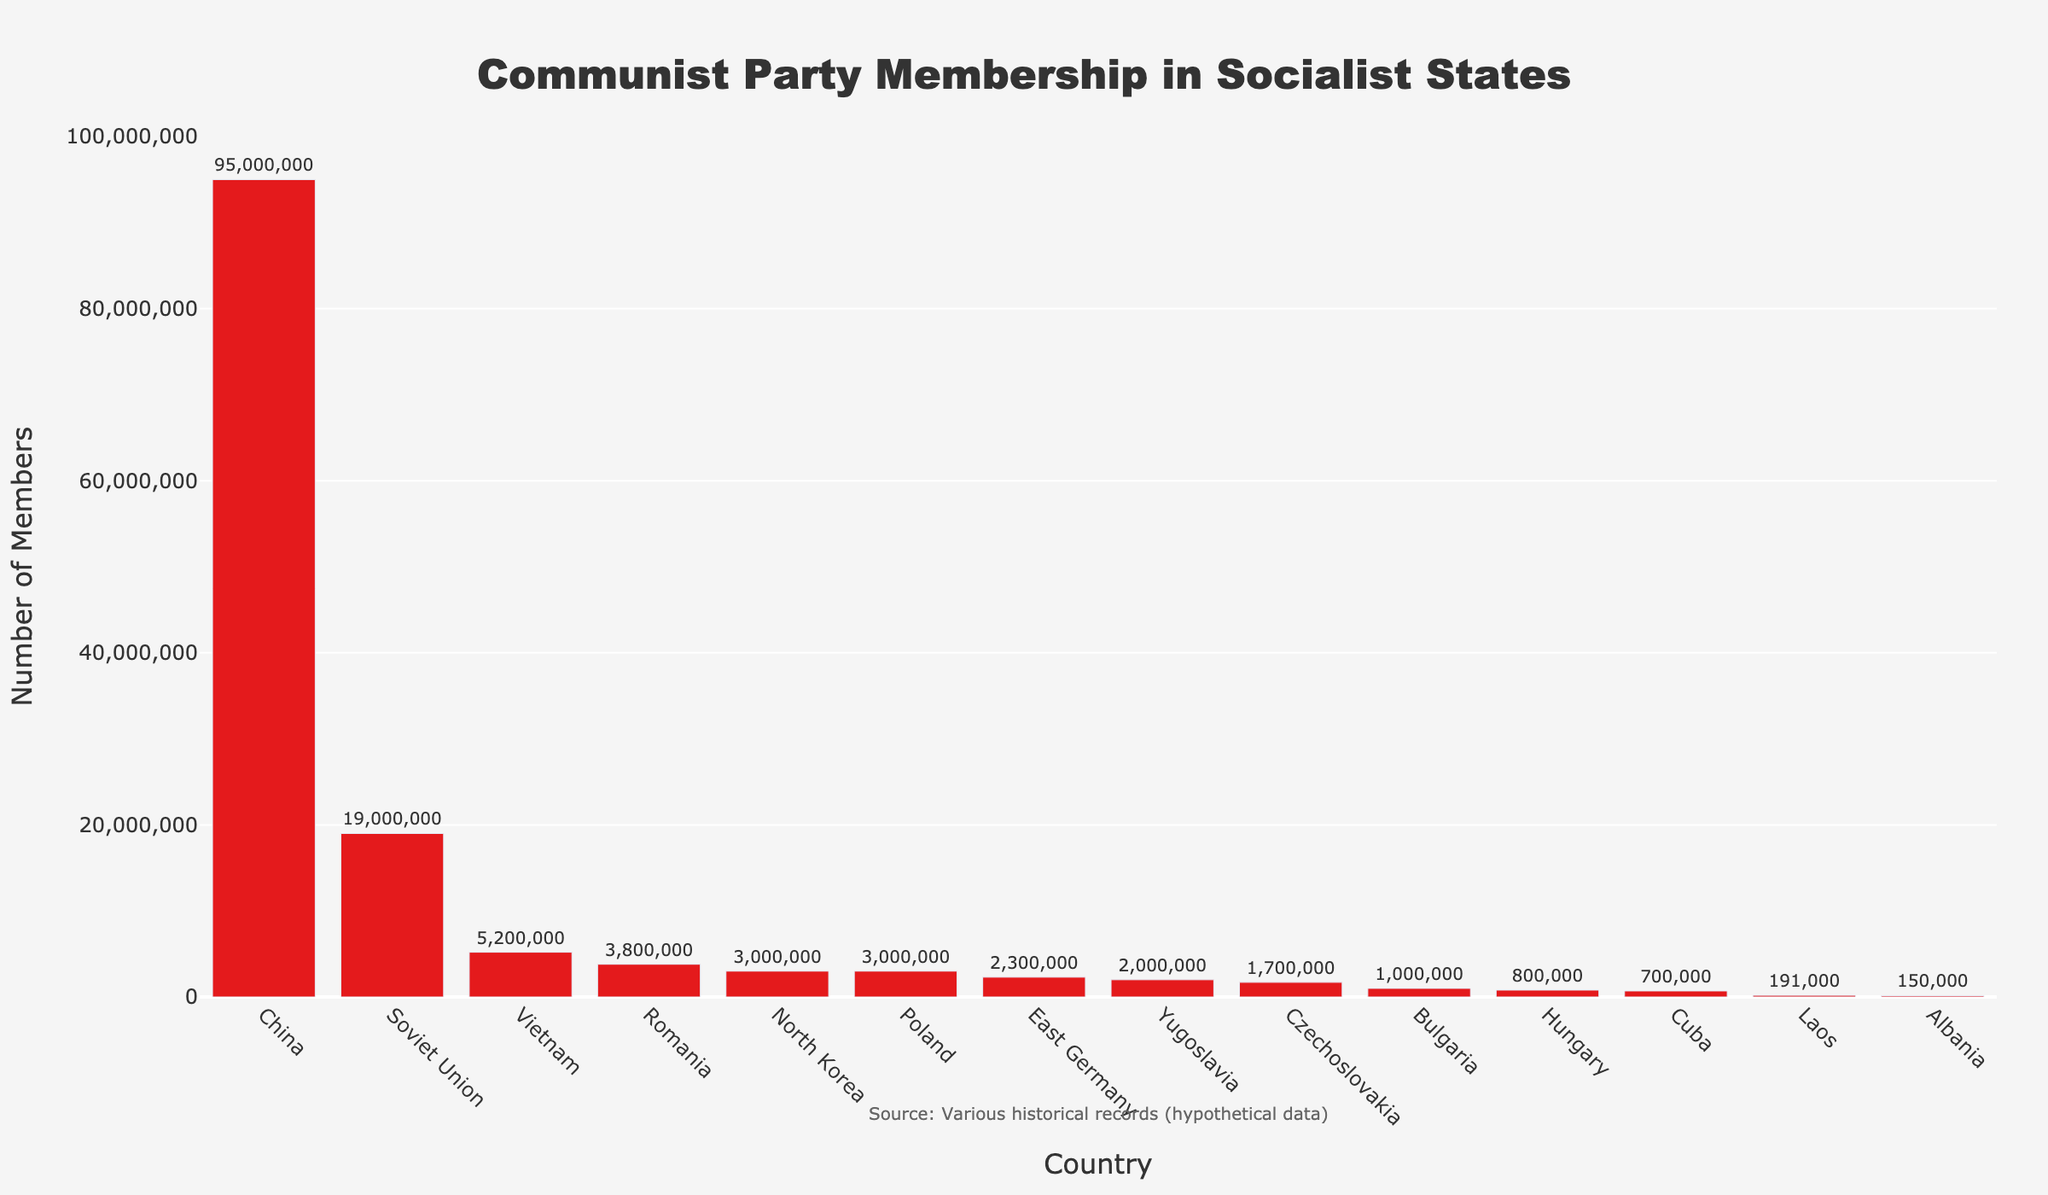what is the country with the second-highest number of Communist Party members? The bar chart shows the number of Communist Party members in several countries. China has the highest number at 95,000,000 members. The country with the second-highest number is the Soviet Union, with 19,000,000 members.
Answer: Soviet Union How many Communist Party members are there in Cuba relative to Vietnam? Look at the heights of the bars for Cuba and Vietnam and note the numbers: Cuba has 700,000 members, and Vietnam has 5,200,000 members. To find the ratio, divide the number of members in Cuba by the number of members in Vietnam: 700,000 / 5,200,000 = 0.1346.
Answer: 0.1346 What is the total number of Communist Party members in all Eastern European countries listed? The Eastern European countries listed are East Germany, Czechoslovakia, Poland, Romania, Bulgaria, Hungary, and Albania. Summing the members: 2,300,000 (East Germany) + 1,700,000 (Czechoslovakia) + 3,000,000 (Poland) + 3,800,000 (Romania) + 1,000,000 (Bulgaria) + 800,000 (Hungary) + 150,000 (Albania) = 12,750,000 members.
Answer: 12,750,000 Which country has the smallest number of Communist Party members? By observing the height of the bars, identify the shortest bar. The country with the smallest number of Communist Party members is Albania, with 150,000 members.
Answer: Albania What's the difference in the number of Communist Party members between the Soviet Union and North Korea? Look at the bars for the Soviet Union and North Korea. The Soviet Union has 19,000,000 members, and North Korea has 3,000,000 members. The difference is 19,000,000 - 3,000,000 = 16,000,000 members.
Answer: 16,000,000 How do the number of Communist Party members in Hungary and Bulgaria compare? The bars for Hungary and Bulgaria show their respective numbers. Hungary has 800,000 members, and Bulgaria has 1,000,000 members. Bulgaria has more members than Hungary.
Answer: Bulgaria has more What is the combined number of Communist Party members in Laos and Albania? Adding the number of members in Laos (191,000) and Albania (150,000), we get: 191,000 + 150,000 = 341,000 members.
Answer: 341,000 If you were to group the countries into those with more than 2,000,000 members and those with fewer, which countries would be in each group? Countries with more than 2,000,000 members: China, Soviet Union, Vietnam, North Korea, East Germany, Poland, Romania, Yugoslavia. Countries with fewer than 2,000,000 members: Cuba, Laos, Czechoslovakia, Bulgaria, Hungary, Albania.
Answer: More than 2M: China, Soviet Union, Vietnam, North Korea, East Germany, Poland, Romania, Yugoslavia. Fewer than 2M: Cuba, Laos, Czechoslovakia, Bulgaria, Hungary, Albania What is the median number of Communist Party members across all listed countries? List the number of members in ascending order: 150,000 (Albania), 191,000 (Laos), 700,000 (Cuba), 800,000 (Hungary), 1,000,000 (Bulgaria), 1,700,000 (Czechoslovakia), 2,000,000 (Yugoslavia), 2,300,000 (East Germany), 3,000,000 (North Korea), 3,800,000 (Romania), 5,200,000 (Vietnam), 19,000,000 (Soviet Union), 95,000,000 (China). With 14 countries, the median will be the 7th and 8th values averaged: (2,000,000 + 2,300,000) / 2 = 2,150,000.
Answer: 2,150,000 